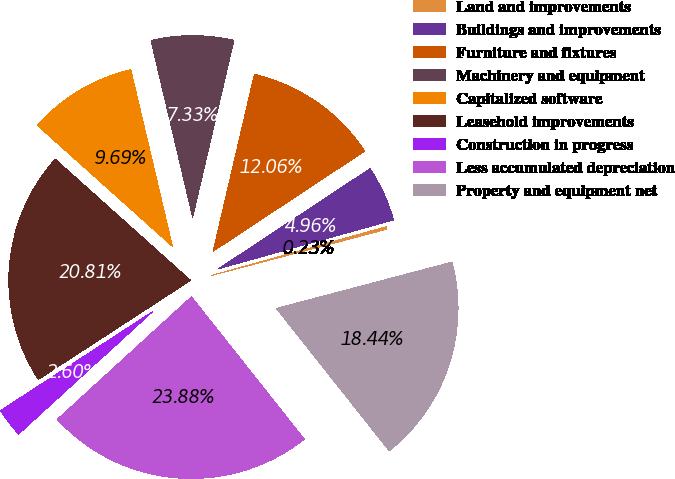Convert chart to OTSL. <chart><loc_0><loc_0><loc_500><loc_500><pie_chart><fcel>Land and improvements<fcel>Buildings and improvements<fcel>Furniture and fixtures<fcel>Machinery and equipment<fcel>Capitalized software<fcel>Leasehold improvements<fcel>Construction in progress<fcel>Less accumulated depreciation<fcel>Property and equipment net<nl><fcel>0.23%<fcel>4.96%<fcel>12.06%<fcel>7.33%<fcel>9.69%<fcel>20.81%<fcel>2.6%<fcel>23.88%<fcel>18.44%<nl></chart> 